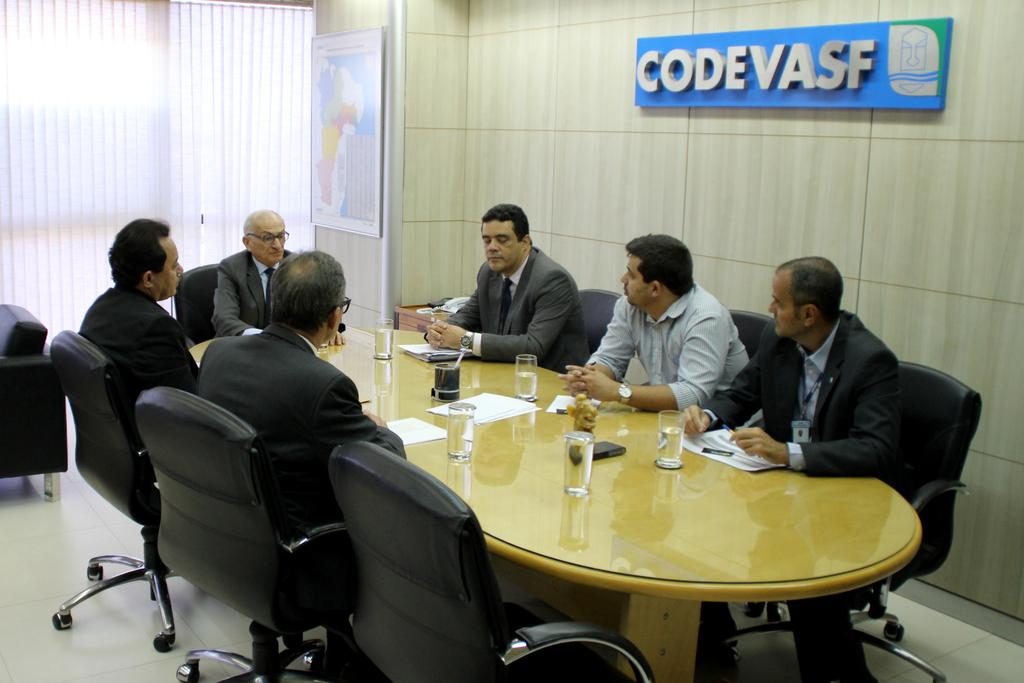<image>
Write a terse but informative summary of the picture. People having a meeting in a room in front of a sign that says "CODEVASF". 